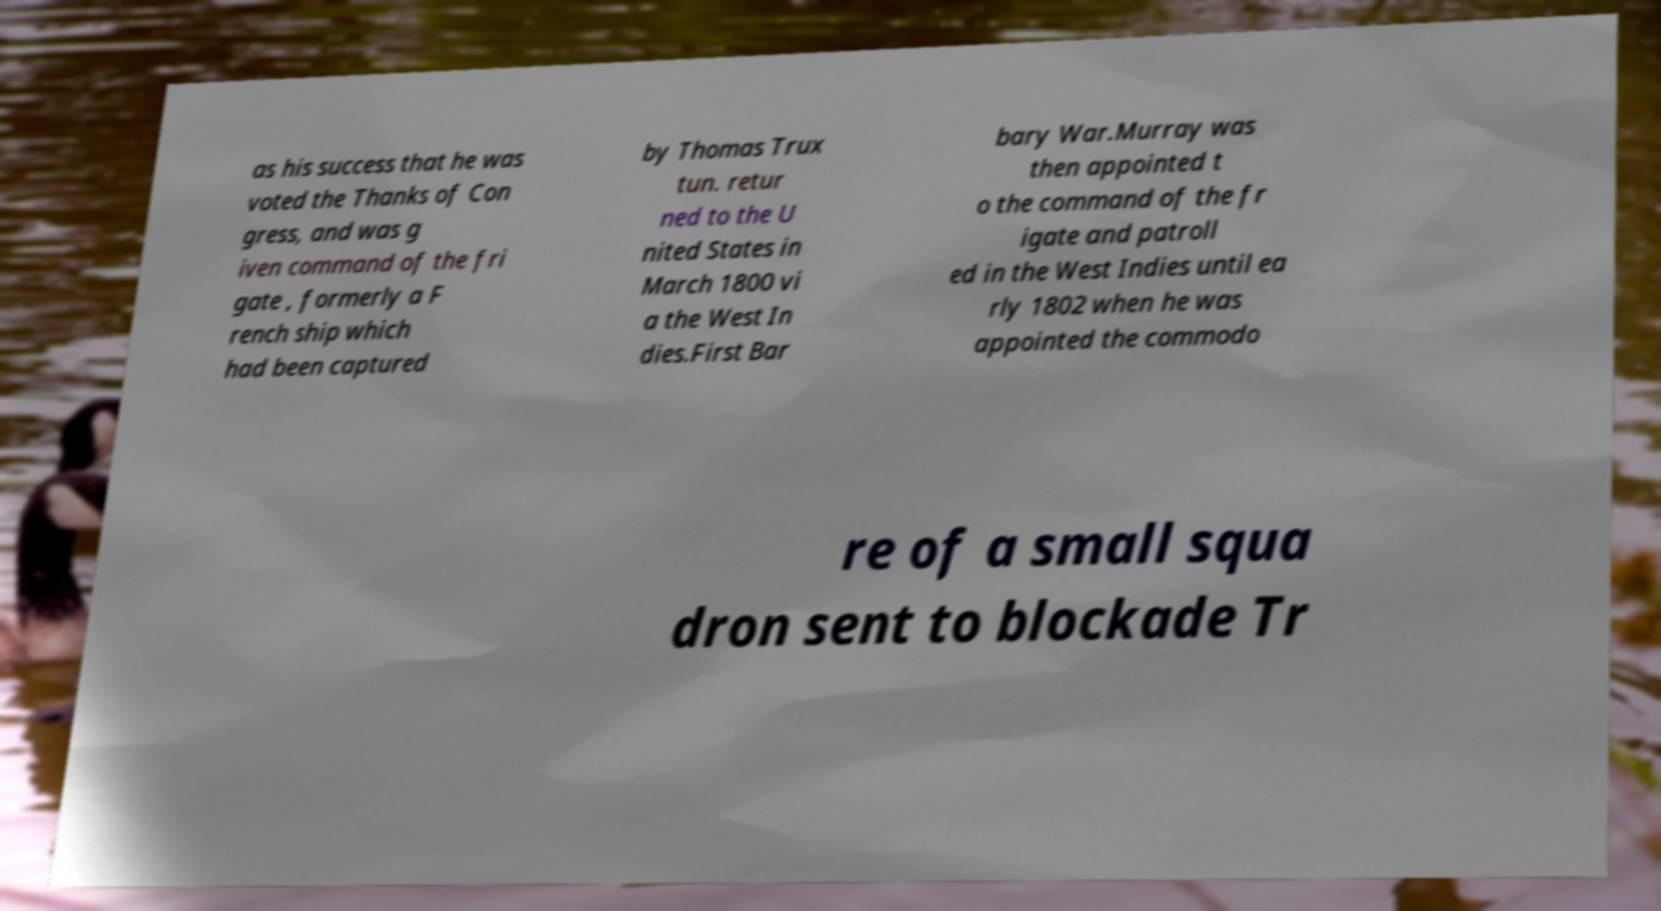I need the written content from this picture converted into text. Can you do that? as his success that he was voted the Thanks of Con gress, and was g iven command of the fri gate , formerly a F rench ship which had been captured by Thomas Trux tun. retur ned to the U nited States in March 1800 vi a the West In dies.First Bar bary War.Murray was then appointed t o the command of the fr igate and patroll ed in the West Indies until ea rly 1802 when he was appointed the commodo re of a small squa dron sent to blockade Tr 